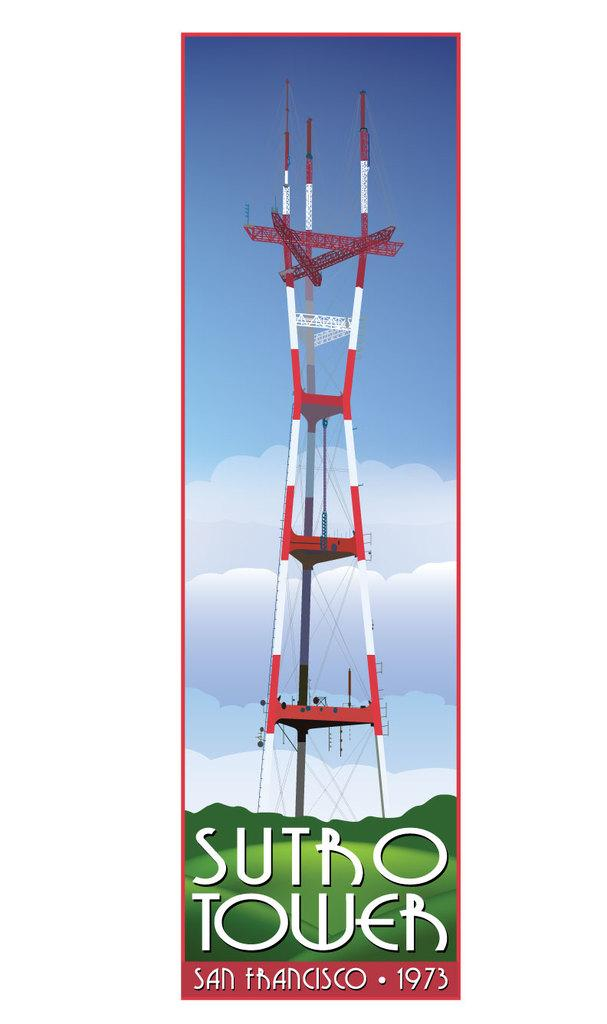<image>
Relay a brief, clear account of the picture shown. A poster of Sutro Tower in San Francisco 1973. 